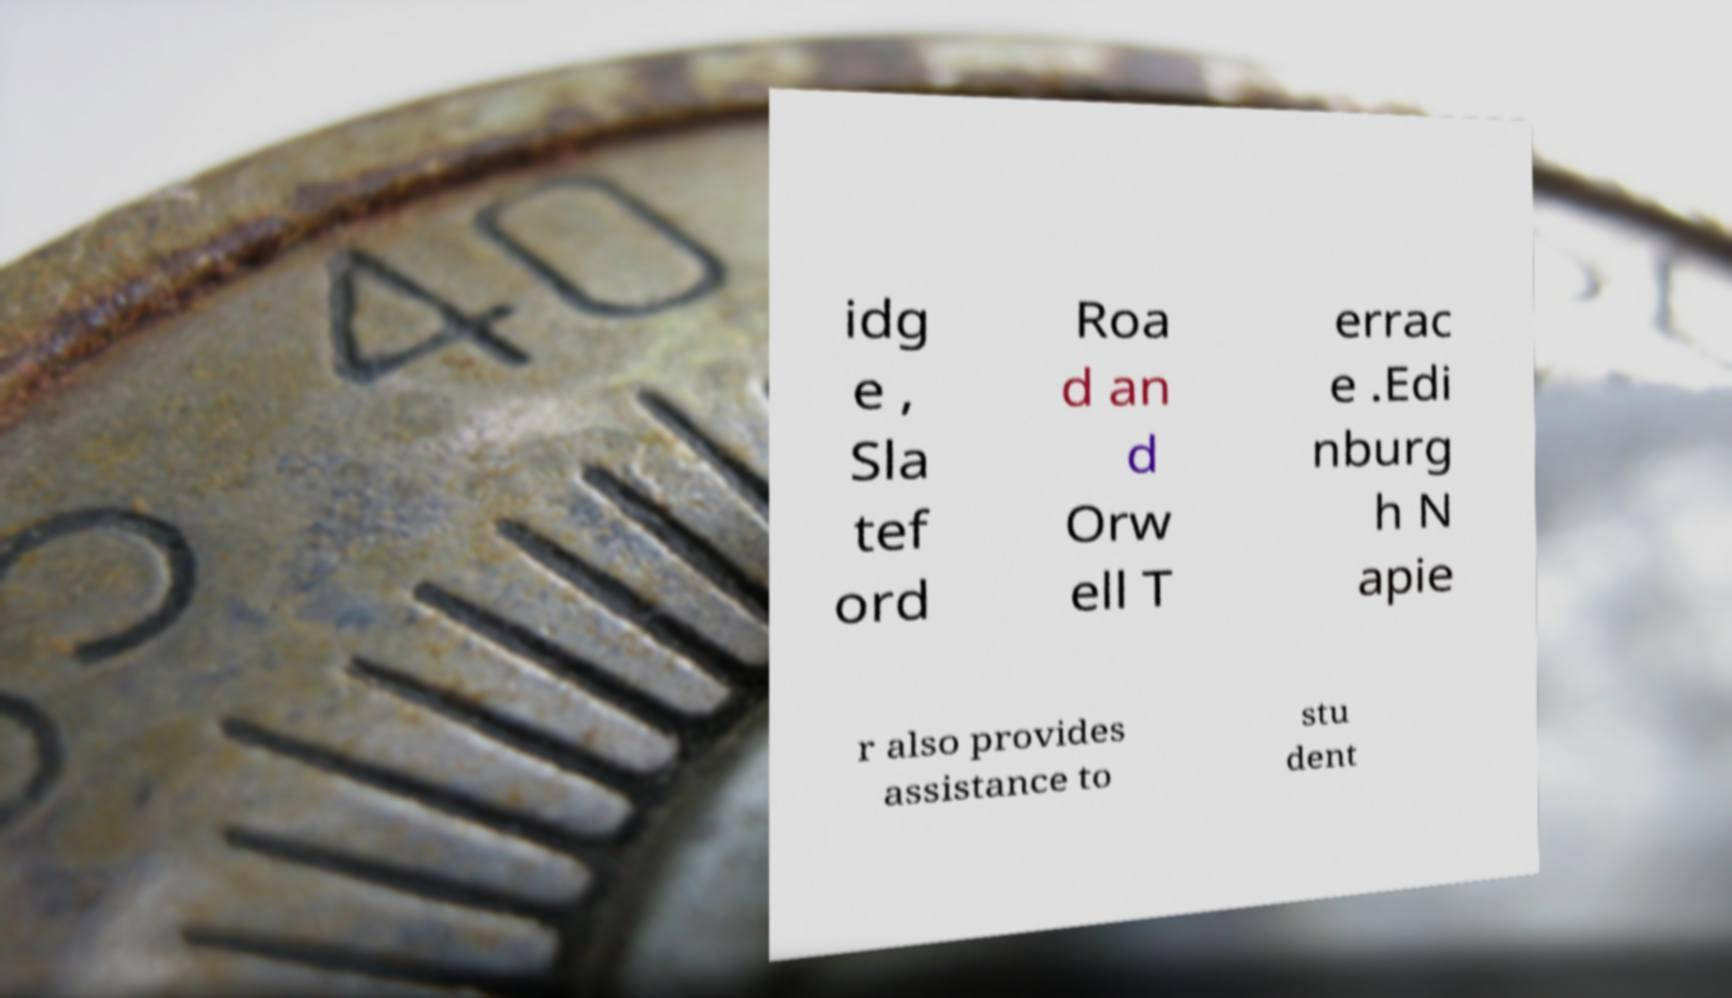Could you assist in decoding the text presented in this image and type it out clearly? idg e , Sla tef ord Roa d an d Orw ell T errac e .Edi nburg h N apie r also provides assistance to stu dent 